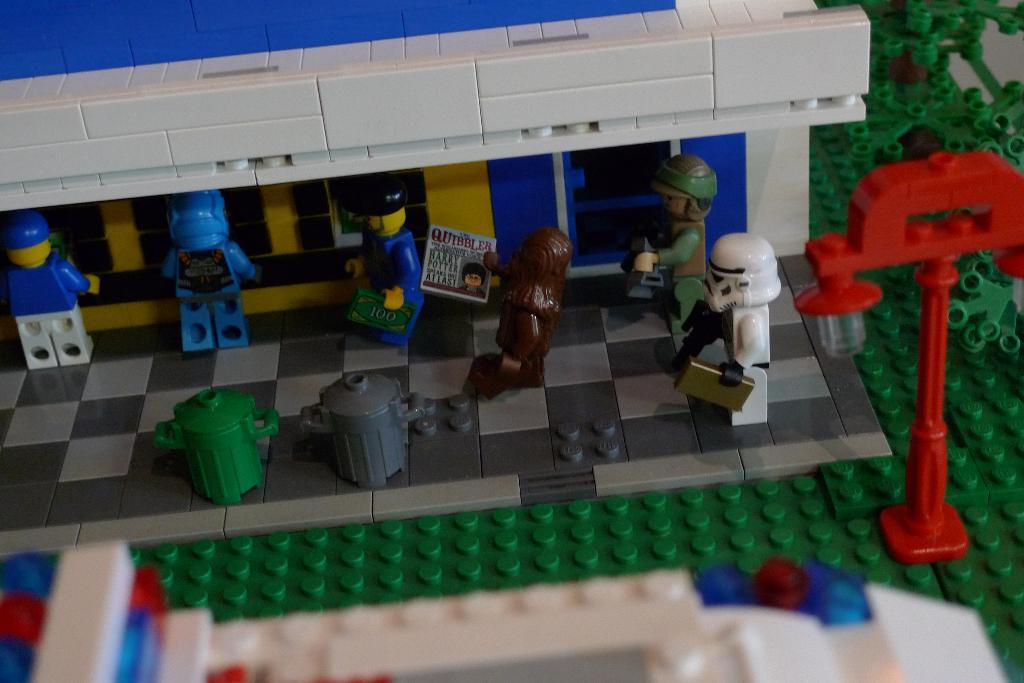What type of objects are present in the image? There are building blocks and toys in the image. Can you describe the condition of the image? The image is slightly blurred in some parts. How do the ducks help with the building blocks in the image? There are no ducks present in the image, so they cannot help with the building blocks. 